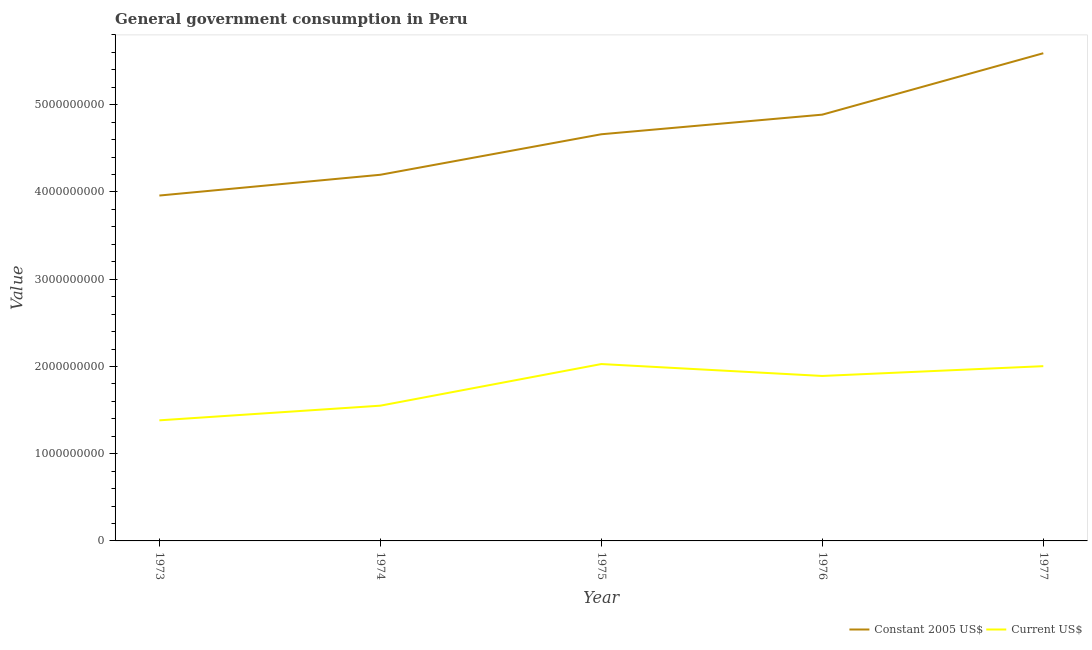How many different coloured lines are there?
Give a very brief answer. 2. Is the number of lines equal to the number of legend labels?
Ensure brevity in your answer.  Yes. What is the value consumed in constant 2005 us$ in 1973?
Provide a short and direct response. 3.96e+09. Across all years, what is the maximum value consumed in current us$?
Ensure brevity in your answer.  2.03e+09. Across all years, what is the minimum value consumed in current us$?
Provide a succinct answer. 1.38e+09. In which year was the value consumed in constant 2005 us$ maximum?
Your answer should be compact. 1977. In which year was the value consumed in current us$ minimum?
Ensure brevity in your answer.  1973. What is the total value consumed in constant 2005 us$ in the graph?
Ensure brevity in your answer.  2.33e+1. What is the difference between the value consumed in current us$ in 1973 and that in 1977?
Keep it short and to the point. -6.21e+08. What is the difference between the value consumed in constant 2005 us$ in 1974 and the value consumed in current us$ in 1976?
Keep it short and to the point. 2.31e+09. What is the average value consumed in constant 2005 us$ per year?
Your answer should be very brief. 4.66e+09. In the year 1975, what is the difference between the value consumed in current us$ and value consumed in constant 2005 us$?
Offer a terse response. -2.63e+09. What is the ratio of the value consumed in constant 2005 us$ in 1974 to that in 1975?
Your answer should be compact. 0.9. Is the value consumed in constant 2005 us$ in 1975 less than that in 1976?
Make the answer very short. Yes. Is the difference between the value consumed in current us$ in 1973 and 1974 greater than the difference between the value consumed in constant 2005 us$ in 1973 and 1974?
Offer a very short reply. Yes. What is the difference between the highest and the second highest value consumed in constant 2005 us$?
Provide a succinct answer. 7.04e+08. What is the difference between the highest and the lowest value consumed in constant 2005 us$?
Your response must be concise. 1.63e+09. Is the sum of the value consumed in constant 2005 us$ in 1974 and 1977 greater than the maximum value consumed in current us$ across all years?
Provide a succinct answer. Yes. Does the value consumed in current us$ monotonically increase over the years?
Give a very brief answer. No. What is the difference between two consecutive major ticks on the Y-axis?
Offer a very short reply. 1.00e+09. Does the graph contain grids?
Ensure brevity in your answer.  No. What is the title of the graph?
Provide a short and direct response. General government consumption in Peru. Does "2012 US$" appear as one of the legend labels in the graph?
Ensure brevity in your answer.  No. What is the label or title of the Y-axis?
Your answer should be compact. Value. What is the Value in Constant 2005 US$ in 1973?
Keep it short and to the point. 3.96e+09. What is the Value of Current US$ in 1973?
Offer a very short reply. 1.38e+09. What is the Value in Constant 2005 US$ in 1974?
Your response must be concise. 4.20e+09. What is the Value in Current US$ in 1974?
Provide a succinct answer. 1.55e+09. What is the Value in Constant 2005 US$ in 1975?
Offer a very short reply. 4.66e+09. What is the Value in Current US$ in 1975?
Your response must be concise. 2.03e+09. What is the Value in Constant 2005 US$ in 1976?
Your answer should be compact. 4.89e+09. What is the Value of Current US$ in 1976?
Provide a succinct answer. 1.89e+09. What is the Value of Constant 2005 US$ in 1977?
Your answer should be compact. 5.59e+09. What is the Value of Current US$ in 1977?
Offer a terse response. 2.00e+09. Across all years, what is the maximum Value of Constant 2005 US$?
Offer a terse response. 5.59e+09. Across all years, what is the maximum Value in Current US$?
Your response must be concise. 2.03e+09. Across all years, what is the minimum Value in Constant 2005 US$?
Your response must be concise. 3.96e+09. Across all years, what is the minimum Value of Current US$?
Keep it short and to the point. 1.38e+09. What is the total Value of Constant 2005 US$ in the graph?
Your answer should be compact. 2.33e+1. What is the total Value of Current US$ in the graph?
Offer a very short reply. 8.85e+09. What is the difference between the Value in Constant 2005 US$ in 1973 and that in 1974?
Your response must be concise. -2.38e+08. What is the difference between the Value in Current US$ in 1973 and that in 1974?
Offer a terse response. -1.68e+08. What is the difference between the Value in Constant 2005 US$ in 1973 and that in 1975?
Provide a succinct answer. -7.03e+08. What is the difference between the Value of Current US$ in 1973 and that in 1975?
Keep it short and to the point. -6.45e+08. What is the difference between the Value in Constant 2005 US$ in 1973 and that in 1976?
Ensure brevity in your answer.  -9.27e+08. What is the difference between the Value of Current US$ in 1973 and that in 1976?
Provide a short and direct response. -5.09e+08. What is the difference between the Value of Constant 2005 US$ in 1973 and that in 1977?
Give a very brief answer. -1.63e+09. What is the difference between the Value of Current US$ in 1973 and that in 1977?
Keep it short and to the point. -6.21e+08. What is the difference between the Value in Constant 2005 US$ in 1974 and that in 1975?
Your answer should be compact. -4.64e+08. What is the difference between the Value of Current US$ in 1974 and that in 1975?
Keep it short and to the point. -4.77e+08. What is the difference between the Value of Constant 2005 US$ in 1974 and that in 1976?
Provide a succinct answer. -6.89e+08. What is the difference between the Value of Current US$ in 1974 and that in 1976?
Your answer should be compact. -3.41e+08. What is the difference between the Value in Constant 2005 US$ in 1974 and that in 1977?
Offer a very short reply. -1.39e+09. What is the difference between the Value in Current US$ in 1974 and that in 1977?
Offer a very short reply. -4.53e+08. What is the difference between the Value in Constant 2005 US$ in 1975 and that in 1976?
Make the answer very short. -2.25e+08. What is the difference between the Value in Current US$ in 1975 and that in 1976?
Your response must be concise. 1.36e+08. What is the difference between the Value of Constant 2005 US$ in 1975 and that in 1977?
Ensure brevity in your answer.  -9.29e+08. What is the difference between the Value of Current US$ in 1975 and that in 1977?
Your response must be concise. 2.43e+07. What is the difference between the Value in Constant 2005 US$ in 1976 and that in 1977?
Provide a succinct answer. -7.04e+08. What is the difference between the Value of Current US$ in 1976 and that in 1977?
Ensure brevity in your answer.  -1.12e+08. What is the difference between the Value in Constant 2005 US$ in 1973 and the Value in Current US$ in 1974?
Make the answer very short. 2.41e+09. What is the difference between the Value in Constant 2005 US$ in 1973 and the Value in Current US$ in 1975?
Your answer should be compact. 1.93e+09. What is the difference between the Value of Constant 2005 US$ in 1973 and the Value of Current US$ in 1976?
Give a very brief answer. 2.07e+09. What is the difference between the Value of Constant 2005 US$ in 1973 and the Value of Current US$ in 1977?
Your answer should be compact. 1.96e+09. What is the difference between the Value of Constant 2005 US$ in 1974 and the Value of Current US$ in 1975?
Offer a very short reply. 2.17e+09. What is the difference between the Value in Constant 2005 US$ in 1974 and the Value in Current US$ in 1976?
Ensure brevity in your answer.  2.31e+09. What is the difference between the Value in Constant 2005 US$ in 1974 and the Value in Current US$ in 1977?
Give a very brief answer. 2.19e+09. What is the difference between the Value of Constant 2005 US$ in 1975 and the Value of Current US$ in 1976?
Your answer should be very brief. 2.77e+09. What is the difference between the Value in Constant 2005 US$ in 1975 and the Value in Current US$ in 1977?
Provide a short and direct response. 2.66e+09. What is the difference between the Value of Constant 2005 US$ in 1976 and the Value of Current US$ in 1977?
Give a very brief answer. 2.88e+09. What is the average Value in Constant 2005 US$ per year?
Your response must be concise. 4.66e+09. What is the average Value in Current US$ per year?
Make the answer very short. 1.77e+09. In the year 1973, what is the difference between the Value in Constant 2005 US$ and Value in Current US$?
Ensure brevity in your answer.  2.58e+09. In the year 1974, what is the difference between the Value of Constant 2005 US$ and Value of Current US$?
Offer a very short reply. 2.65e+09. In the year 1975, what is the difference between the Value in Constant 2005 US$ and Value in Current US$?
Provide a succinct answer. 2.63e+09. In the year 1976, what is the difference between the Value in Constant 2005 US$ and Value in Current US$?
Your answer should be compact. 3.00e+09. In the year 1977, what is the difference between the Value of Constant 2005 US$ and Value of Current US$?
Your answer should be very brief. 3.59e+09. What is the ratio of the Value in Constant 2005 US$ in 1973 to that in 1974?
Ensure brevity in your answer.  0.94. What is the ratio of the Value of Current US$ in 1973 to that in 1974?
Your answer should be very brief. 0.89. What is the ratio of the Value of Constant 2005 US$ in 1973 to that in 1975?
Keep it short and to the point. 0.85. What is the ratio of the Value of Current US$ in 1973 to that in 1975?
Make the answer very short. 0.68. What is the ratio of the Value of Constant 2005 US$ in 1973 to that in 1976?
Give a very brief answer. 0.81. What is the ratio of the Value in Current US$ in 1973 to that in 1976?
Make the answer very short. 0.73. What is the ratio of the Value in Constant 2005 US$ in 1973 to that in 1977?
Offer a very short reply. 0.71. What is the ratio of the Value in Current US$ in 1973 to that in 1977?
Offer a very short reply. 0.69. What is the ratio of the Value of Constant 2005 US$ in 1974 to that in 1975?
Keep it short and to the point. 0.9. What is the ratio of the Value in Current US$ in 1974 to that in 1975?
Your answer should be very brief. 0.76. What is the ratio of the Value in Constant 2005 US$ in 1974 to that in 1976?
Offer a very short reply. 0.86. What is the ratio of the Value of Current US$ in 1974 to that in 1976?
Ensure brevity in your answer.  0.82. What is the ratio of the Value in Constant 2005 US$ in 1974 to that in 1977?
Keep it short and to the point. 0.75. What is the ratio of the Value of Current US$ in 1974 to that in 1977?
Make the answer very short. 0.77. What is the ratio of the Value in Constant 2005 US$ in 1975 to that in 1976?
Give a very brief answer. 0.95. What is the ratio of the Value in Current US$ in 1975 to that in 1976?
Keep it short and to the point. 1.07. What is the ratio of the Value in Constant 2005 US$ in 1975 to that in 1977?
Your answer should be very brief. 0.83. What is the ratio of the Value of Current US$ in 1975 to that in 1977?
Your response must be concise. 1.01. What is the ratio of the Value in Constant 2005 US$ in 1976 to that in 1977?
Offer a very short reply. 0.87. What is the ratio of the Value of Current US$ in 1976 to that in 1977?
Make the answer very short. 0.94. What is the difference between the highest and the second highest Value of Constant 2005 US$?
Give a very brief answer. 7.04e+08. What is the difference between the highest and the second highest Value in Current US$?
Keep it short and to the point. 2.43e+07. What is the difference between the highest and the lowest Value in Constant 2005 US$?
Your response must be concise. 1.63e+09. What is the difference between the highest and the lowest Value in Current US$?
Your answer should be very brief. 6.45e+08. 